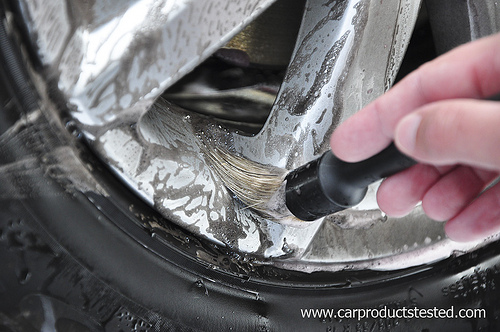<image>
Can you confirm if the brush is on the rim? Yes. Looking at the image, I can see the brush is positioned on top of the rim, with the rim providing support. 